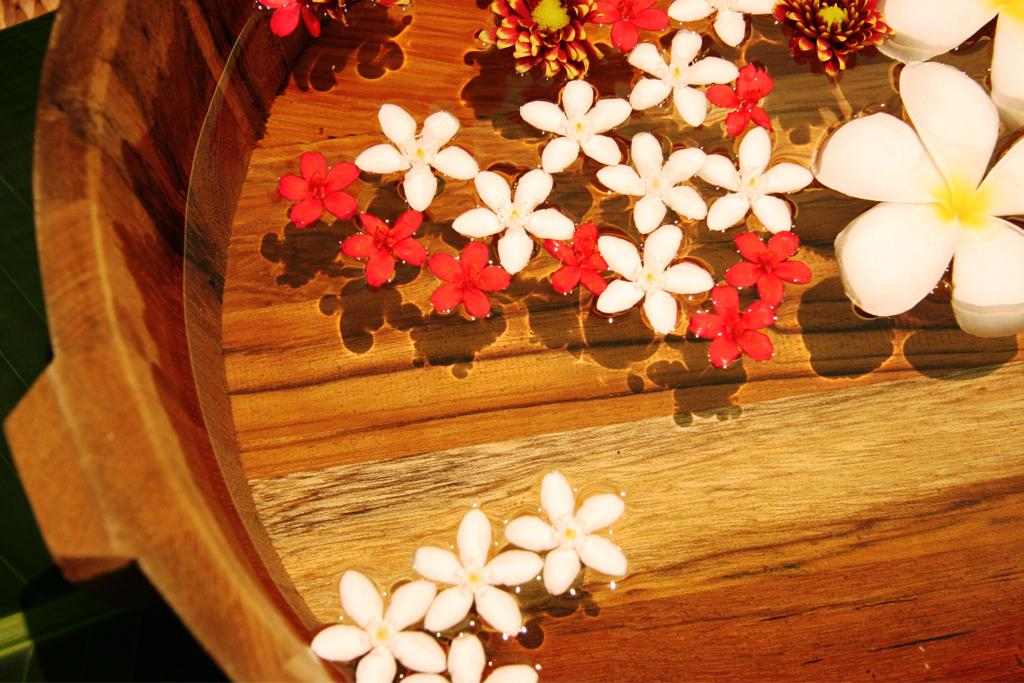What type of plants are in the image? There are flowers in the image. How are the flowers arranged or contained in the image? The flowers are in water and placed in a tub. What statement can be made about the limit of the flowers in the image? There is no mention of a limit or restriction on the flowers in the image, so it cannot be determined from the image. 